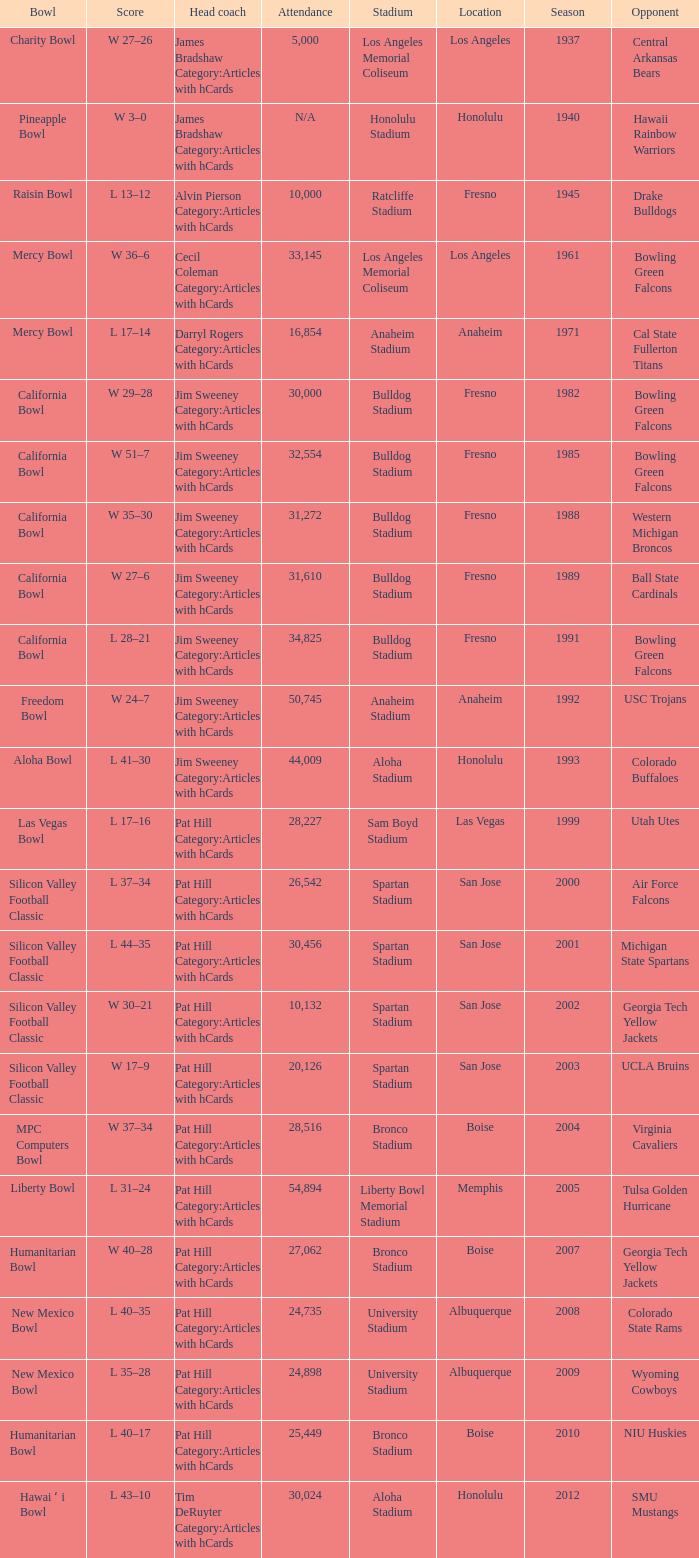Where was the California bowl played with 30,000 attending? Fresno. 